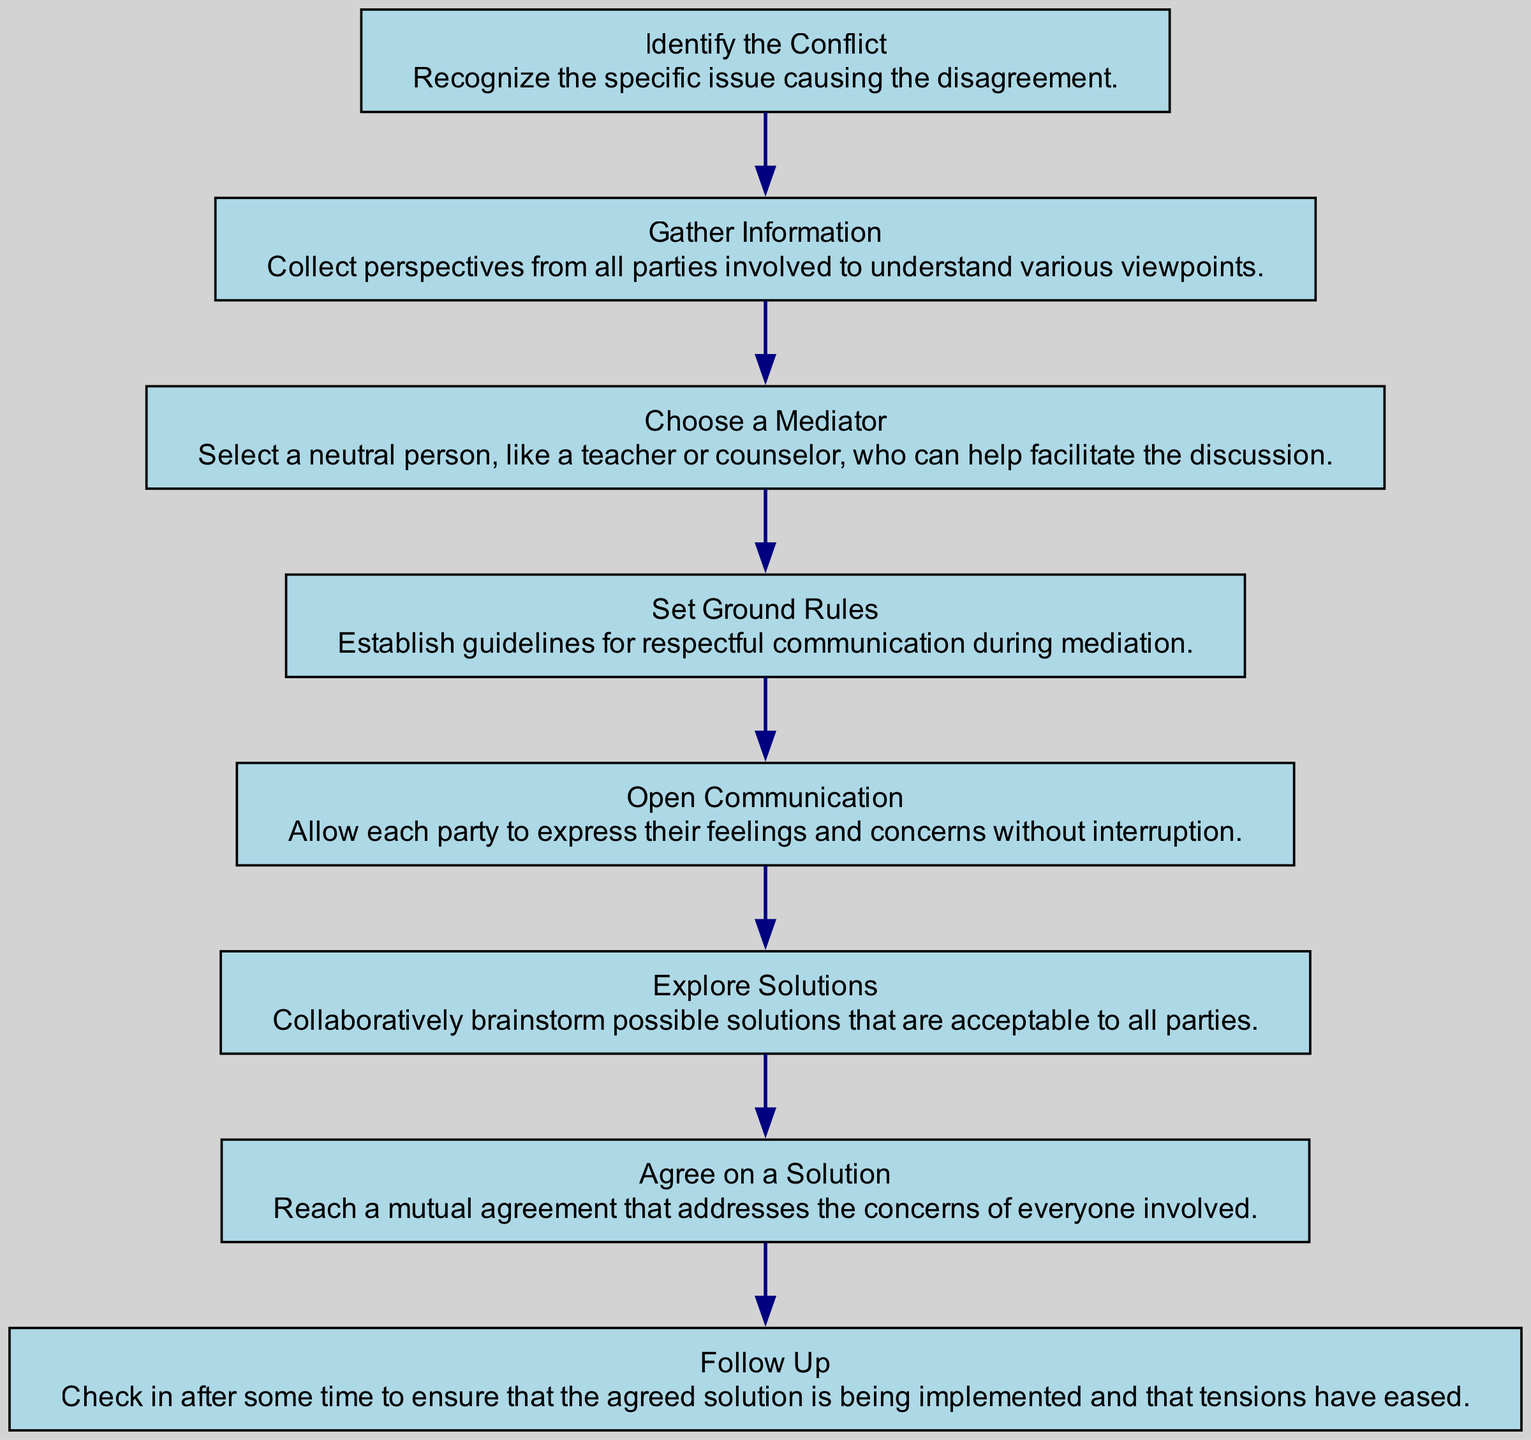What is the first step in the mediation process? The first step is to identify the conflict, which involves recognizing the specific issue causing the disagreement.
Answer: Identify the Conflict How many nodes are present in the diagram? There are eight nodes representing each step in the mediation process, from identifying the conflict to following up.
Answer: Eight Which node comes after "Gather Information"? The node that comes after "Gather Information" is "Choose a Mediator". This follows the natural flow of the steps in the mediation process.
Answer: Choose a Mediator What is the purpose of "Set Ground Rules" in the flow chart? "Set Ground Rules" establishes guidelines for respectful communication during mediation, ensuring that the discussions remain constructive.
Answer: Establish guidelines Which steps must be completed before reaching the "Agree on a Solution"? The steps that must be completed before reaching "Agree on a Solution" are "Open Communication" and "Explore Solutions". This shows the necessary progression to arrive at a mutual agreement.
Answer: Open Communication and Explore Solutions How many connections are there between the nodes? There are seven connections (edges) between the eight nodes, as each node connects to the next in the flow chart.
Answer: Seven What happens after an agreement is reached in the mediation process? After an agreement is reached, the next step is to follow up, which involves checking in after some time to ensure the agreed solution is working effectively.
Answer: Follow Up What kind of person should be chosen as a mediator? A neutral person such as a teacher or counselor should be chosen as a mediator, as they can help facilitate the discussion without taking sides.
Answer: Neutral person What does "Open Communication" allow parties to do? "Open Communication" allows each party to express their feelings and concerns without interruption, promoting a better understanding of each other's viewpoints.
Answer: Express feelings and concerns 